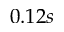<formula> <loc_0><loc_0><loc_500><loc_500>0 . 1 2 s</formula> 